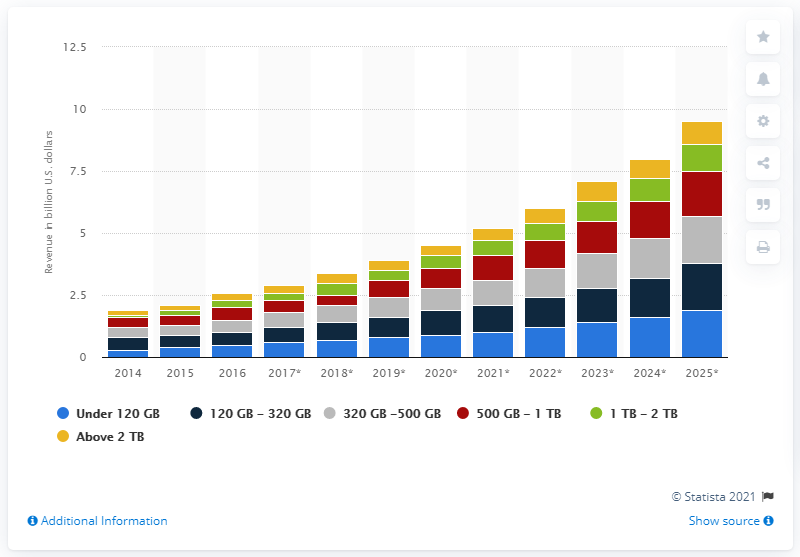Specify some key components in this picture. The market value of SSDs with storage space between 120 and 320 GB is expected to reach in the United States in 2018. This value is expected to be around 0.7. 